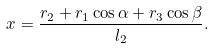<formula> <loc_0><loc_0><loc_500><loc_500>x = \frac { r _ { 2 } + r _ { 1 } \cos \alpha + r _ { 3 } \cos \beta } { l _ { 2 } } .</formula> 